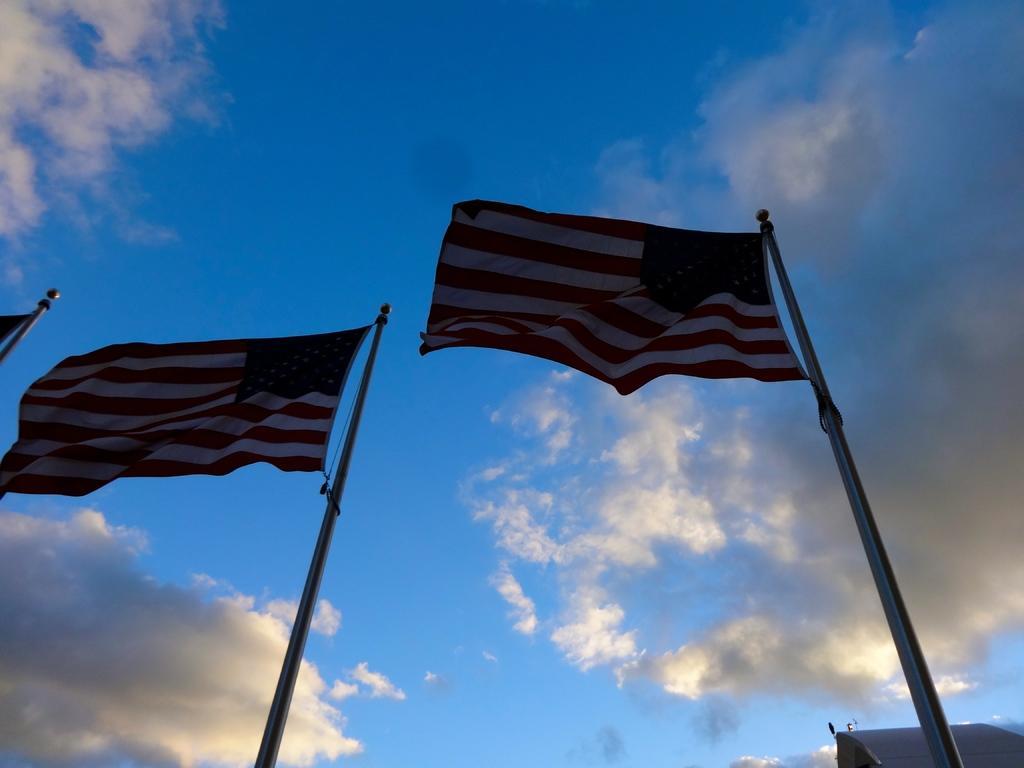Please provide a concise description of this image. In this image we can see flags and poles. In the background of the image there is the sky. On the right side of the image there is an object. 